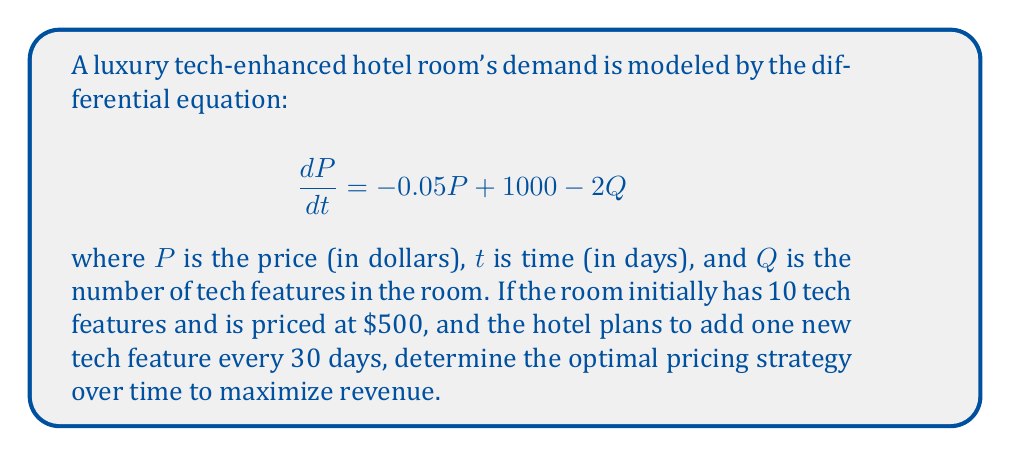Can you solve this math problem? To solve this problem, we need to follow these steps:

1) First, we need to recognize that $Q$ is a function of time. Since one new tech feature is added every 30 days, we can express $Q$ as:

   $Q = 10 + \frac{t}{30}$

2) Substituting this into our original differential equation:

   $$\frac{dP}{dt} = -0.05P + 1000 - 2(10 + \frac{t}{30})$$
   $$\frac{dP}{dt} = -0.05P + 1000 - 20 - \frac{t}{15}$$
   $$\frac{dP}{dt} = -0.05P + 980 - \frac{t}{15}$$

3) This is a first-order linear differential equation of the form:

   $$\frac{dP}{dt} + 0.05P = 980 - \frac{t}{15}$$

4) To solve this, we use the integrating factor method. The integrating factor is:

   $$\mu(t) = e^{\int 0.05 dt} = e^{0.05t}$$

5) Multiplying both sides of the equation by $\mu(t)$:

   $$e^{0.05t}\frac{dP}{dt} + 0.05e^{0.05t}P = 980e^{0.05t} - \frac{t}{15}e^{0.05t}$$

6) The left side is now the derivative of $e^{0.05t}P$. So we can write:

   $$\frac{d}{dt}(e^{0.05t}P) = 980e^{0.05t} - \frac{t}{15}e^{0.05t}$$

7) Integrating both sides:

   $$e^{0.05t}P = \int (980e^{0.05t} - \frac{t}{15}e^{0.05t}) dt$$
   $$e^{0.05t}P = 19600e^{0.05t} - \frac{1}{15}(\frac{t}{0.05} - \frac{1}{0.05^2})e^{0.05t} + C$$

8) Dividing both sides by $e^{0.05t}$:

   $$P = 19600 - \frac{1}{15}(\frac{t}{0.05} - \frac{1}{0.05^2}) + Ce^{-0.05t}$$

9) Using the initial condition $P(0) = 500$, we can find $C$:

   $$500 = 19600 + \frac{1}{15 \cdot 0.05^2} + C$$
   $$C = 500 - 19600 - \frac{1}{15 \cdot 0.05^2} \approx -19433.33$$

10) Therefore, the optimal pricing strategy over time is:

    $$P(t) = 19600 - \frac{1}{15}(\frac{t}{0.05} - \frac{1}{0.05^2}) - 19433.33e^{-0.05t}$$
Answer: The optimal pricing strategy for the luxury tech-enhanced hotel room over time is given by the function:

$$P(t) = 19600 - \frac{1}{15}(\frac{t}{0.05} - \frac{1}{0.05^2}) - 19433.33e^{-0.05t}$$

where $P$ is the price in dollars and $t$ is time in days. 